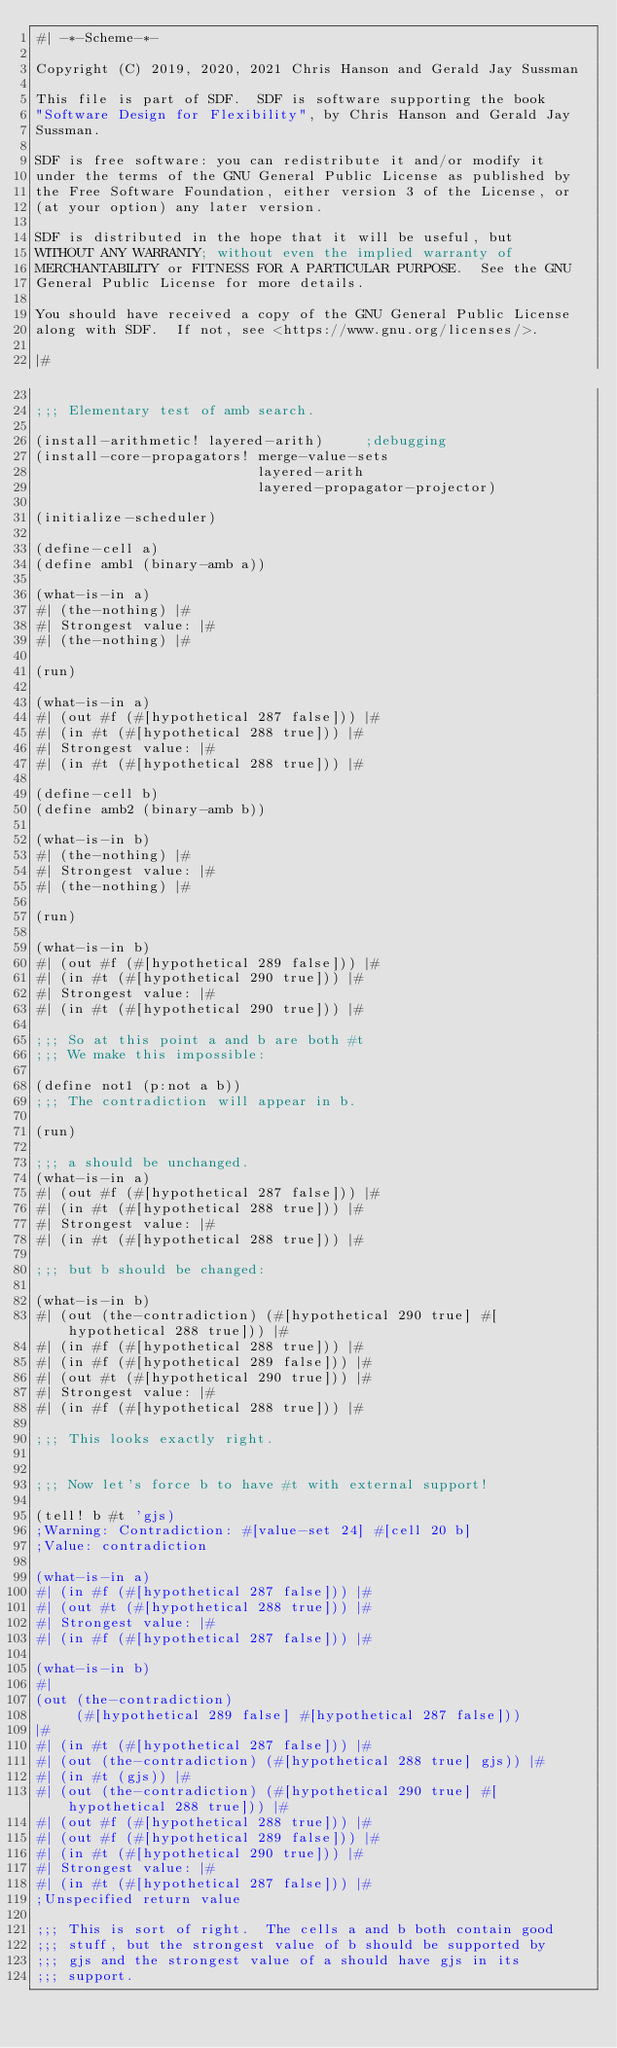Convert code to text. <code><loc_0><loc_0><loc_500><loc_500><_Scheme_>#| -*-Scheme-*-

Copyright (C) 2019, 2020, 2021 Chris Hanson and Gerald Jay Sussman

This file is part of SDF.  SDF is software supporting the book
"Software Design for Flexibility", by Chris Hanson and Gerald Jay
Sussman.

SDF is free software: you can redistribute it and/or modify it
under the terms of the GNU General Public License as published by
the Free Software Foundation, either version 3 of the License, or
(at your option) any later version.

SDF is distributed in the hope that it will be useful, but
WITHOUT ANY WARRANTY; without even the implied warranty of
MERCHANTABILITY or FITNESS FOR A PARTICULAR PURPOSE.  See the GNU
General Public License for more details.

You should have received a copy of the GNU General Public License
along with SDF.  If not, see <https://www.gnu.org/licenses/>.

|#

;;; Elementary test of amb search.

(install-arithmetic! layered-arith)     ;debugging
(install-core-propagators! merge-value-sets
                           layered-arith
                           layered-propagator-projector)

(initialize-scheduler)

(define-cell a)
(define amb1 (binary-amb a))

(what-is-in a)
#| (the-nothing) |#
#| Strongest value: |#
#| (the-nothing) |#

(run)

(what-is-in a)
#| (out #f (#[hypothetical 287 false])) |#
#| (in #t (#[hypothetical 288 true])) |#
#| Strongest value: |#
#| (in #t (#[hypothetical 288 true])) |#

(define-cell b)
(define amb2 (binary-amb b))

(what-is-in b)
#| (the-nothing) |#
#| Strongest value: |#
#| (the-nothing) |#

(run)

(what-is-in b)
#| (out #f (#[hypothetical 289 false])) |#
#| (in #t (#[hypothetical 290 true])) |#
#| Strongest value: |#
#| (in #t (#[hypothetical 290 true])) |#

;;; So at this point a and b are both #t
;;; We make this impossible:

(define not1 (p:not a b))
;;; The contradiction will appear in b.

(run)

;;; a should be unchanged.
(what-is-in a)
#| (out #f (#[hypothetical 287 false])) |#
#| (in #t (#[hypothetical 288 true])) |#
#| Strongest value: |#
#| (in #t (#[hypothetical 288 true])) |#

;;; but b should be changed:

(what-is-in b)
#| (out (the-contradiction) (#[hypothetical 290 true] #[hypothetical 288 true])) |#
#| (in #f (#[hypothetical 288 true])) |#
#| (in #f (#[hypothetical 289 false])) |#
#| (out #t (#[hypothetical 290 true])) |#
#| Strongest value: |#
#| (in #f (#[hypothetical 288 true])) |#

;;; This looks exactly right.


;;; Now let's force b to have #t with external support!

(tell! b #t 'gjs)
;Warning: Contradiction: #[value-set 24] #[cell 20 b]
;Value: contradiction

(what-is-in a)
#| (in #f (#[hypothetical 287 false])) |#
#| (out #t (#[hypothetical 288 true])) |#
#| Strongest value: |#
#| (in #f (#[hypothetical 287 false])) |#

(what-is-in b)
#|
(out (the-contradiction)
     (#[hypothetical 289 false] #[hypothetical 287 false]))
|#
#| (in #t (#[hypothetical 287 false])) |#
#| (out (the-contradiction) (#[hypothetical 288 true] gjs)) |#
#| (in #t (gjs)) |#
#| (out (the-contradiction) (#[hypothetical 290 true] #[hypothetical 288 true])) |#
#| (out #f (#[hypothetical 288 true])) |#
#| (out #f (#[hypothetical 289 false])) |#
#| (in #t (#[hypothetical 290 true])) |#
#| Strongest value: |#
#| (in #t (#[hypothetical 287 false])) |#
;Unspecified return value

;;; This is sort of right.  The cells a and b both contain good
;;; stuff, but the strongest value of b should be supported by
;;; gjs and the strongest value of a should have gjs in its
;;; support.
</code> 